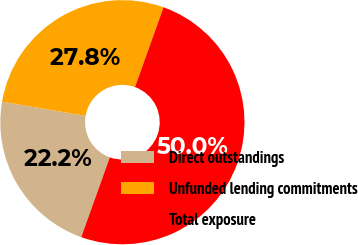<chart> <loc_0><loc_0><loc_500><loc_500><pie_chart><fcel>Direct outstandings<fcel>Unfunded lending commitments<fcel>Total exposure<nl><fcel>22.22%<fcel>27.78%<fcel>50.0%<nl></chart> 